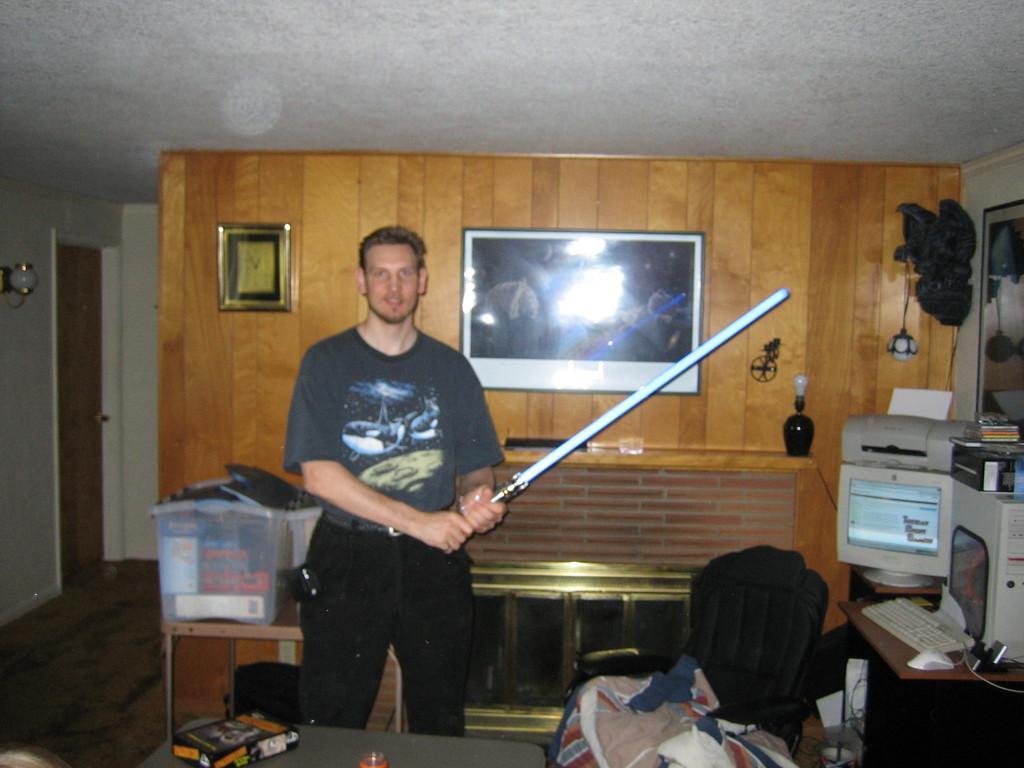Could you give a brief overview of what you see in this image? In this image there is a person standing and holding sword, behind him there is a TV and clock on the wall, also there is a computer on the table and in front of him there is a table with so many things. 